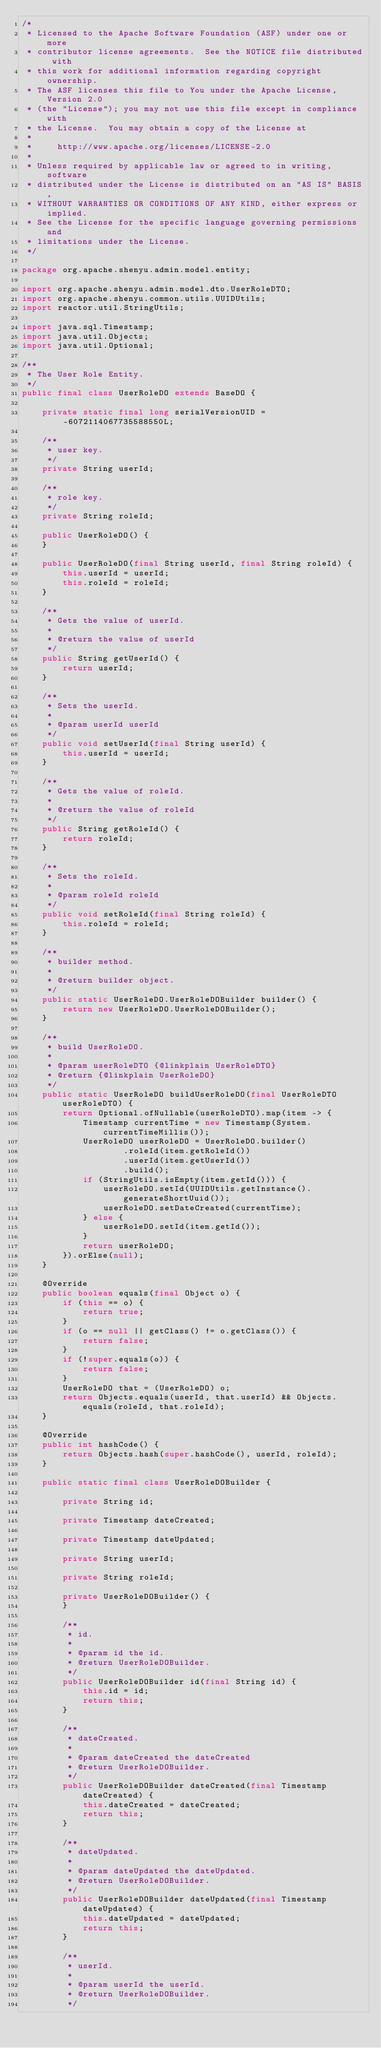Convert code to text. <code><loc_0><loc_0><loc_500><loc_500><_Java_>/*
 * Licensed to the Apache Software Foundation (ASF) under one or more
 * contributor license agreements.  See the NOTICE file distributed with
 * this work for additional information regarding copyright ownership.
 * The ASF licenses this file to You under the Apache License, Version 2.0
 * (the "License"); you may not use this file except in compliance with
 * the License.  You may obtain a copy of the License at
 *
 *     http://www.apache.org/licenses/LICENSE-2.0
 *
 * Unless required by applicable law or agreed to in writing, software
 * distributed under the License is distributed on an "AS IS" BASIS,
 * WITHOUT WARRANTIES OR CONDITIONS OF ANY KIND, either express or implied.
 * See the License for the specific language governing permissions and
 * limitations under the License.
 */

package org.apache.shenyu.admin.model.entity;

import org.apache.shenyu.admin.model.dto.UserRoleDTO;
import org.apache.shenyu.common.utils.UUIDUtils;
import reactor.util.StringUtils;

import java.sql.Timestamp;
import java.util.Objects;
import java.util.Optional;

/**
 * The User Role Entity.
 */
public final class UserRoleDO extends BaseDO {

    private static final long serialVersionUID = -6072114067735588550L;

    /**
     * user key.
     */
    private String userId;

    /**
     * role key.
     */
    private String roleId;

    public UserRoleDO() {
    }

    public UserRoleDO(final String userId, final String roleId) {
        this.userId = userId;
        this.roleId = roleId;
    }

    /**
     * Gets the value of userId.
     *
     * @return the value of userId
     */
    public String getUserId() {
        return userId;
    }

    /**
     * Sets the userId.
     *
     * @param userId userId
     */
    public void setUserId(final String userId) {
        this.userId = userId;
    }

    /**
     * Gets the value of roleId.
     *
     * @return the value of roleId
     */
    public String getRoleId() {
        return roleId;
    }

    /**
     * Sets the roleId.
     *
     * @param roleId roleId
     */
    public void setRoleId(final String roleId) {
        this.roleId = roleId;
    }

    /**
     * builder method.
     *
     * @return builder object.
     */
    public static UserRoleDO.UserRoleDOBuilder builder() {
        return new UserRoleDO.UserRoleDOBuilder();
    }

    /**
     * build UserRoleDO.
     *
     * @param userRoleDTO {@linkplain UserRoleDTO}
     * @return {@linkplain UserRoleDO}
     */
    public static UserRoleDO buildUserRoleDO(final UserRoleDTO userRoleDTO) {
        return Optional.ofNullable(userRoleDTO).map(item -> {
            Timestamp currentTime = new Timestamp(System.currentTimeMillis());
            UserRoleDO userRoleDO = UserRoleDO.builder()
                    .roleId(item.getRoleId())
                    .userId(item.getUserId())
                    .build();
            if (StringUtils.isEmpty(item.getId())) {
                userRoleDO.setId(UUIDUtils.getInstance().generateShortUuid());
                userRoleDO.setDateCreated(currentTime);
            } else {
                userRoleDO.setId(item.getId());
            }
            return userRoleDO;
        }).orElse(null);
    }

    @Override
    public boolean equals(final Object o) {
        if (this == o) {
            return true;
        }
        if (o == null || getClass() != o.getClass()) {
            return false;
        }
        if (!super.equals(o)) {
            return false;
        }
        UserRoleDO that = (UserRoleDO) o;
        return Objects.equals(userId, that.userId) && Objects.equals(roleId, that.roleId);
    }

    @Override
    public int hashCode() {
        return Objects.hash(super.hashCode(), userId, roleId);
    }

    public static final class UserRoleDOBuilder {

        private String id;

        private Timestamp dateCreated;

        private Timestamp dateUpdated;

        private String userId;

        private String roleId;

        private UserRoleDOBuilder() {
        }

        /**
         * id.
         *
         * @param id the id.
         * @return UserRoleDOBuilder.
         */
        public UserRoleDOBuilder id(final String id) {
            this.id = id;
            return this;
        }

        /**
         * dateCreated.
         *
         * @param dateCreated the dateCreated
         * @return UserRoleDOBuilder.
         */
        public UserRoleDOBuilder dateCreated(final Timestamp dateCreated) {
            this.dateCreated = dateCreated;
            return this;
        }

        /**
         * dateUpdated.
         *
         * @param dateUpdated the dateUpdated.
         * @return UserRoleDOBuilder.
         */
        public UserRoleDOBuilder dateUpdated(final Timestamp dateUpdated) {
            this.dateUpdated = dateUpdated;
            return this;
        }

        /**
         * userId.
         *
         * @param userId the userId.
         * @return UserRoleDOBuilder.
         */</code> 